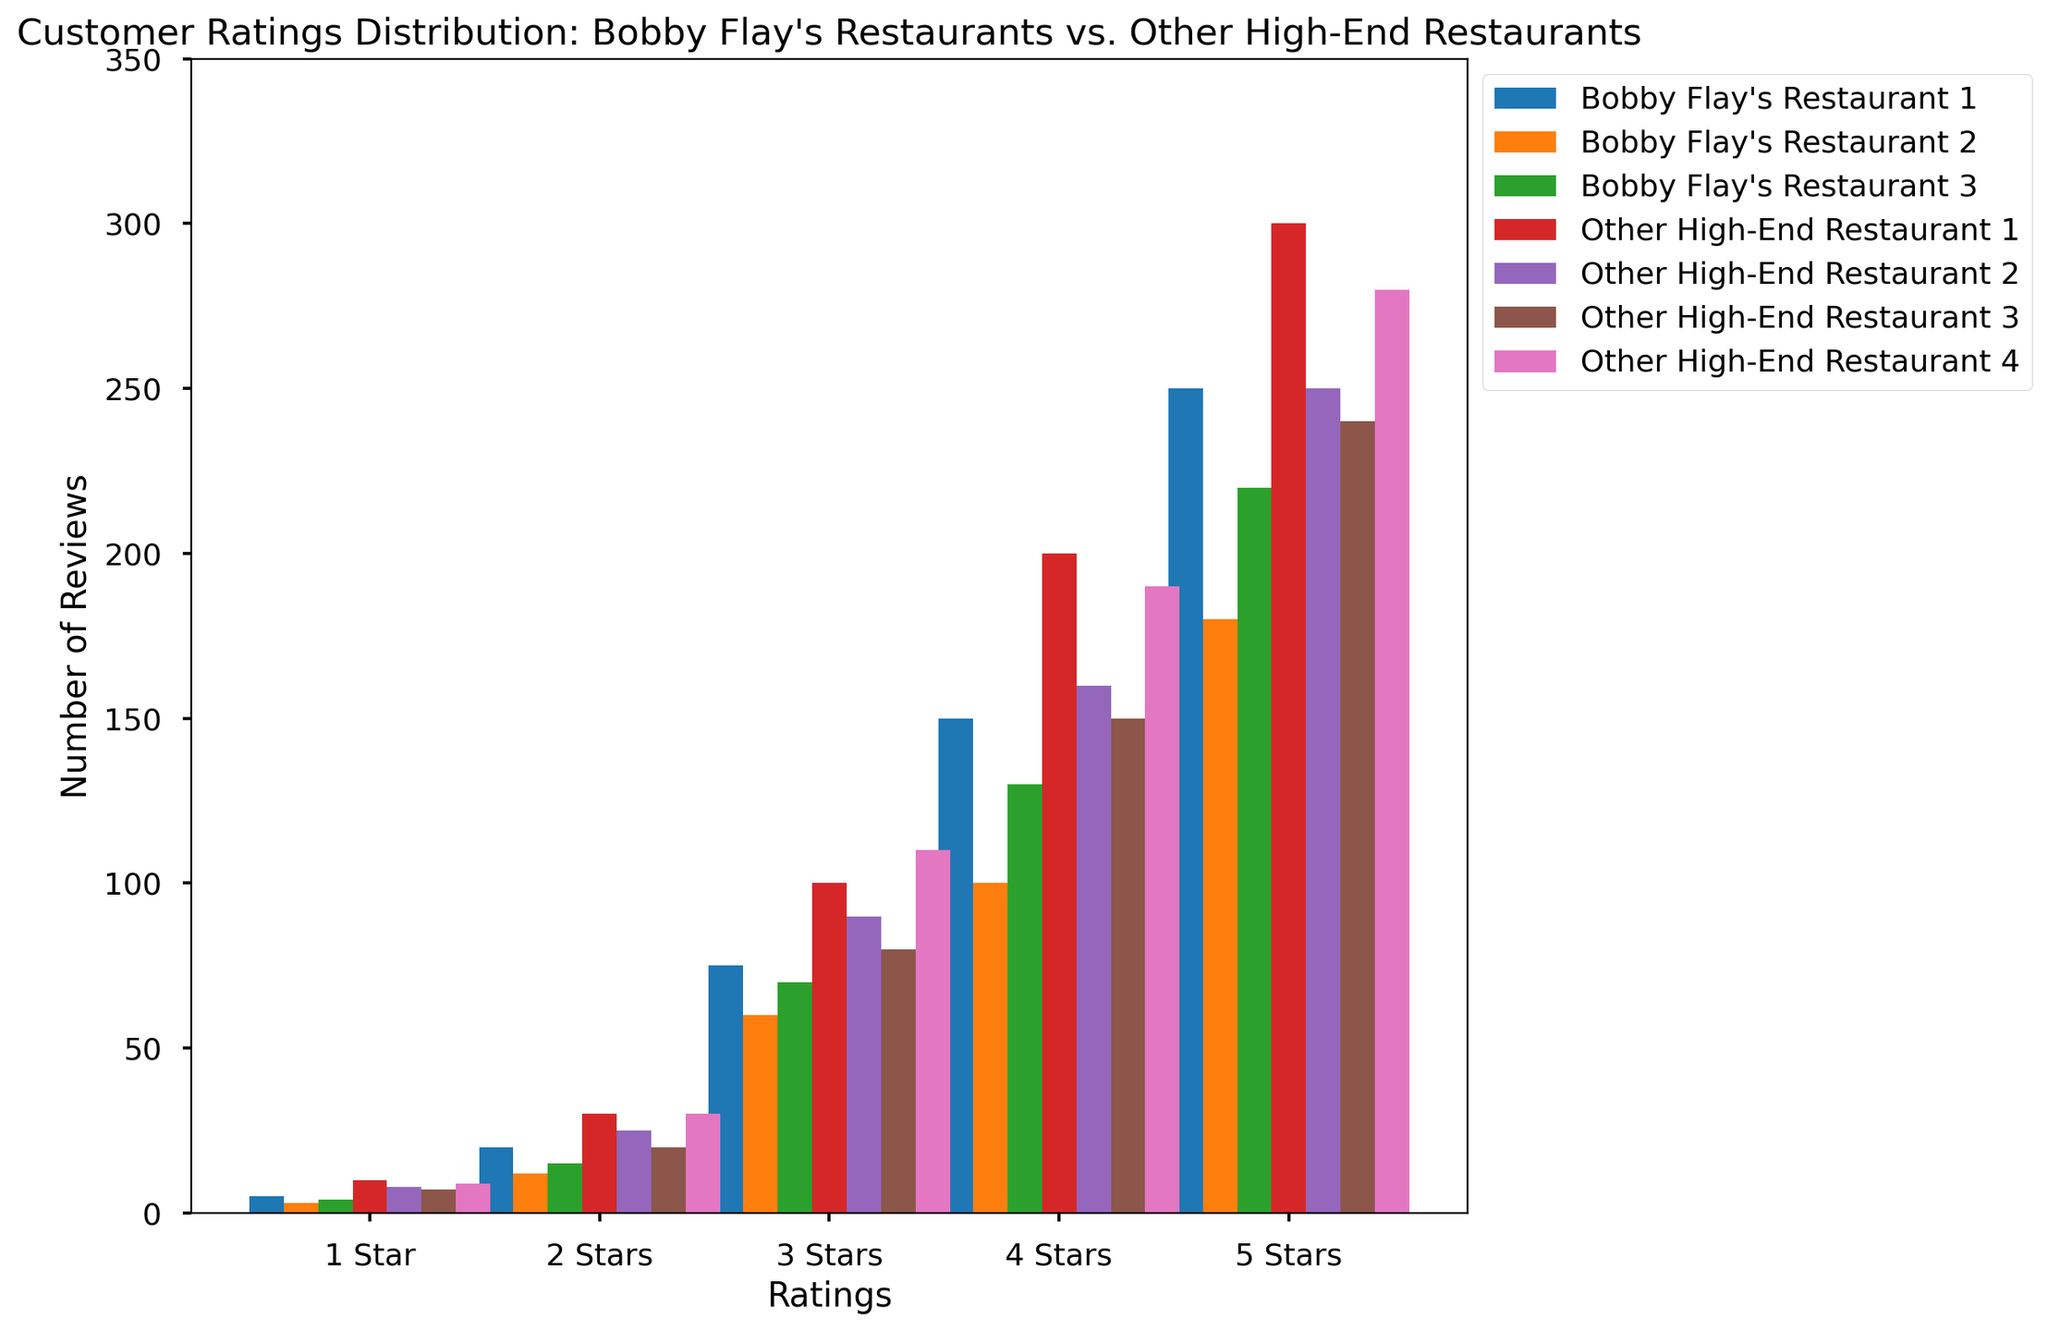Which restaurant has the highest number of 5-star reviews? To find the restaurant with the highest number of 5-star reviews, look for the tallest bar in the "5 Stars" category. The highest bar corresponds to "Other High-End Restaurant 1" with 300 reviews.
Answer: Other High-End Restaurant 1 How many 1-star reviews do Bobby Flay's restaurants have in total? Add up the number of 1-star reviews for all Bobby Flay's restaurants: 5 (Restaurant 1) + 3 (Restaurant 2) + 4 (Restaurant 3). The total is 5 + 3 + 4 = 12.
Answer: 12 Which restaurant has more 4-star reviews, Bobby Flay's Restaurant 2 or Other High-End Restaurant 4? Compare the height of the bars in the "4 Stars" category for Bobby Flay’s Restaurant 2 and Other High-End Restaurant 4. Bobby Flay’s Restaurant 2 has 100 reviews, while Other High-End Restaurant 4 has 190 reviews.
Answer: Other High-End Restaurant 4 What is the average number of 3-star reviews for Bobby Flay's restaurants? To calculate the average, add all the 3-star reviews for Bobby Flay's restaurants and divide by the number of restaurants. (75 + 60 + 70) / 3 = 205 / 3 ≈ 68.33.
Answer: 68.33 Do any Bobby Flay’s restaurants have more 2-star reviews than Other High-End Restaurant 2? Compare the 2-star reviews: Bobby Flay's Restaurant 1 has 20, Restaurant 2 has 12, and Restaurant 3 has 15. Other High-End Restaurant 2 has 25. None of Bobby Flay’s restaurants exceed 25.
Answer: No What is the difference in the number of 1-star reviews between Bobby Flay's Restaurant 1 and Other High-End Restaurant 3? Subtract the number of 1-star reviews of Other High-End Restaurant 3 (7) from Bobby Flay's Restaurant 1 (5). 5 - 7 = -2.
Answer: -2 Which has more variability in 5-star reviews, Bobby Flay’s restaurants or Other High-End restaurants? Compare the range (max - min) of the 5-star reviews. For Bobby Flay’s restaurants: max (250) - min (180) = 70. For Other High-End restaurants: max (300) - min (240) = 60. Bobby Flay’s restaurants show more variability.
Answer: Bobby Flay’s restaurants What percentage of Bobby Flay's Restaurant 3 reviews are 5-star reviews? Divide the number of 5-star reviews by the total number of reviews and multiply by 100. (220 / (4 + 15 + 70 + 130 + 220)) * 100 ≈ 57.59%.
Answer: 57.59% How do the 4-star reviews of Other High-End Restaurant 1 compare to the 3-star reviews of Bobby Flay's Restaurant 1? Compare the numbers directly: Other High-End Restaurant 1 has 200 4-star reviews and Bobby Flay’s Restaurant 1 has 75 3-star reviews. 200 > 75.
Answer: Other High-End Restaurant 1 has more If you sum all the 5-star reviews for both Bobby Flay's and Other High-End restaurants, which type has more reviews in total? Sum the 5-star reviews for Bobby Flay’s restaurants (250 + 180 + 220 = 650) and Other High-End restaurants (300 + 250 + 240 + 280 = 1070). Compare 650 to 1070. Other High-End restaurants have more.
Answer: Other High-End restaurants 